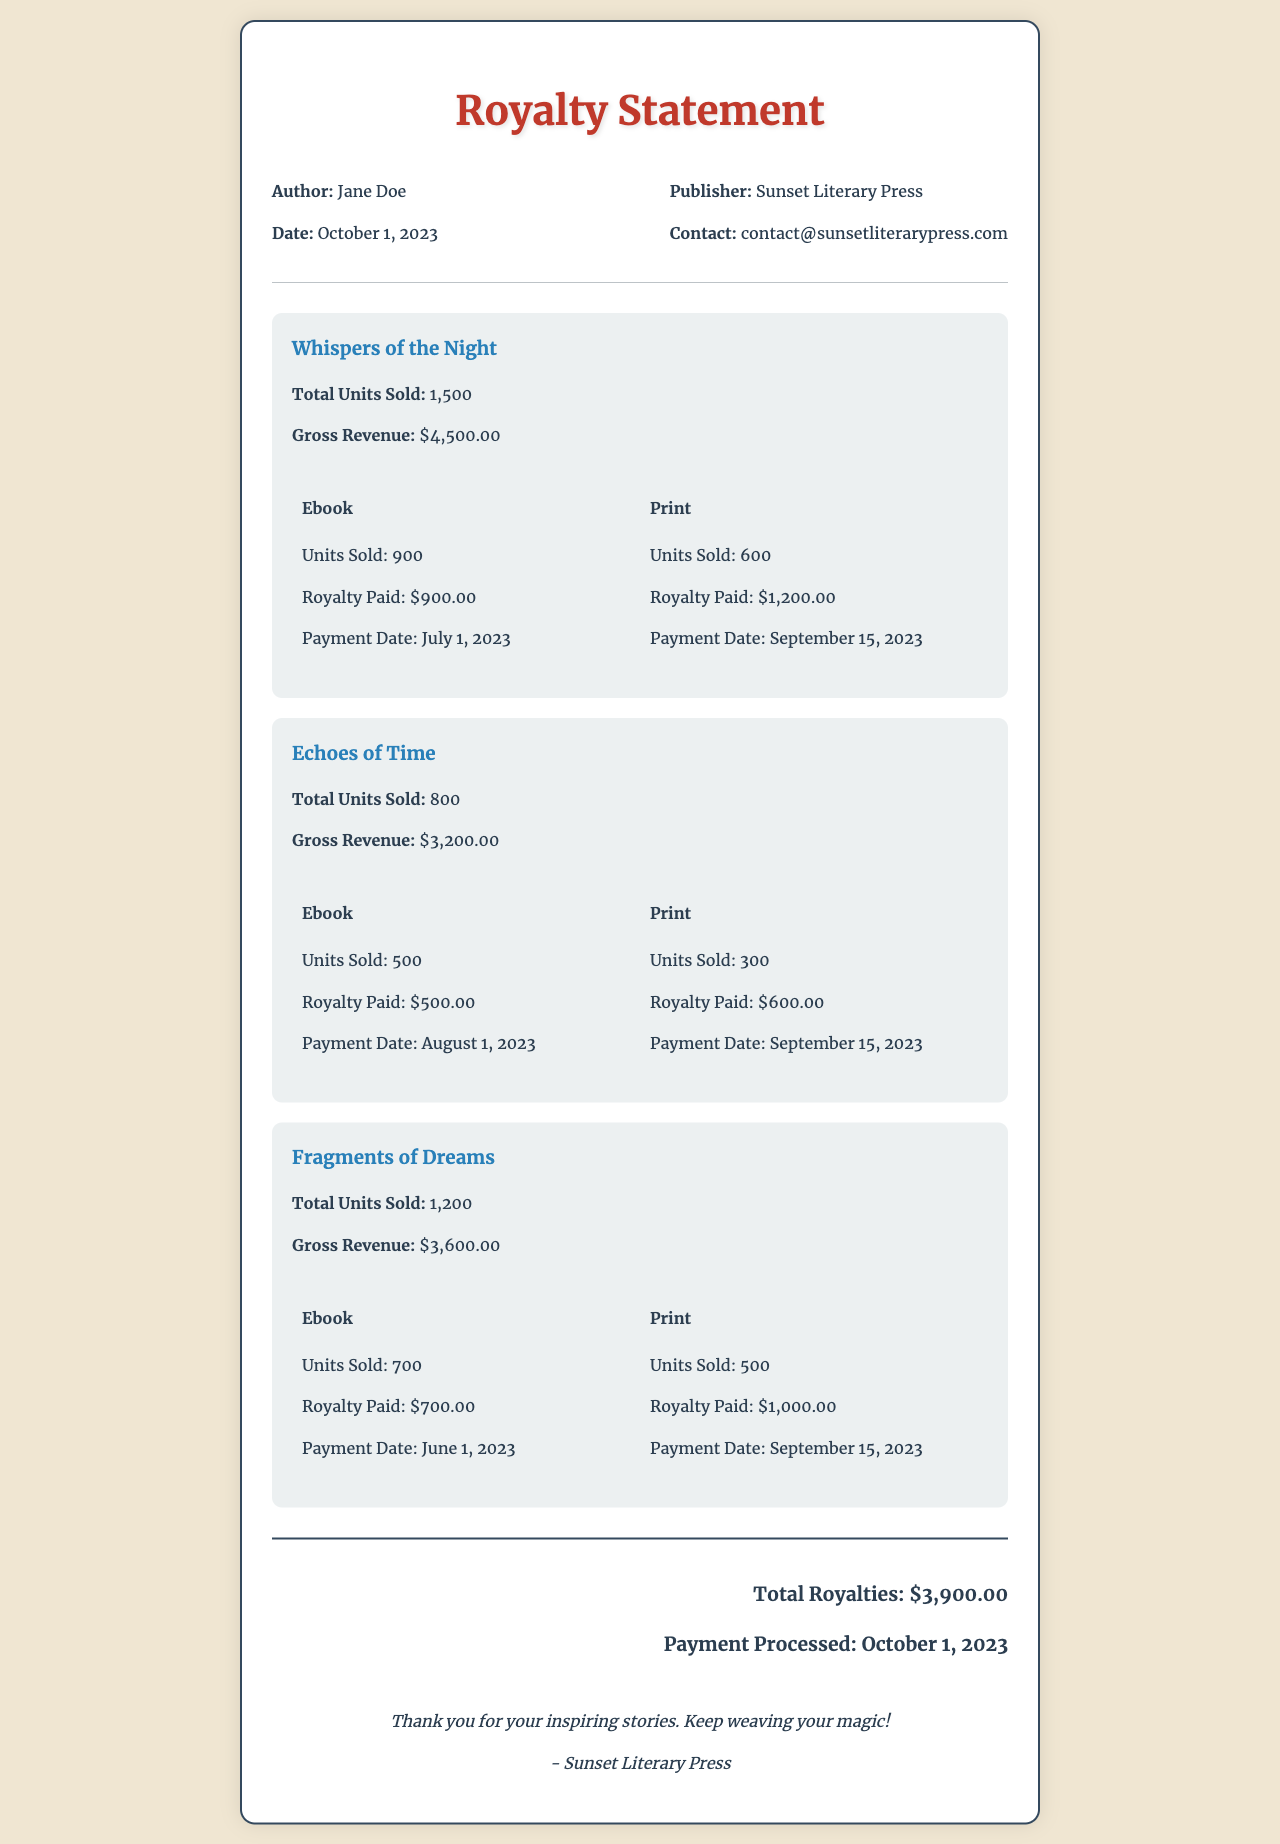What is the author's name? The author's name is mentioned in the document header.
Answer: Jane Doe What is the date of the royalty statement? The date is specified in the header of the document.
Answer: October 1, 2023 How many total units were sold for "Whispers of the Night"? The total units sold for each book are listed under the book title.
Answer: 1,500 What payment amount was made for the ebook of "Echoes of Time"? The royalty paid for the ebook is included in the breakdown section for the book.
Answer: $500.00 When was the payment processed for "Fragments of Dreams"? The processed payment date is provided at the bottom of the document.
Answer: October 1, 2023 How much total royalty was received from all sales? The total royalties are summed up at the end of the document.
Answer: $3,900.00 Which title had the largest number of units sold? A comparison of the total units sold for each book indicates which had the most sales.
Answer: Whispers of the Night What is the publisher's name? The publisher's name is found in the header section of the document.
Answer: Sunset Literary Press How many units of print were sold for "Fragments of Dreams"? The units sold for print are detailed in the book's breakdown section.
Answer: 500 